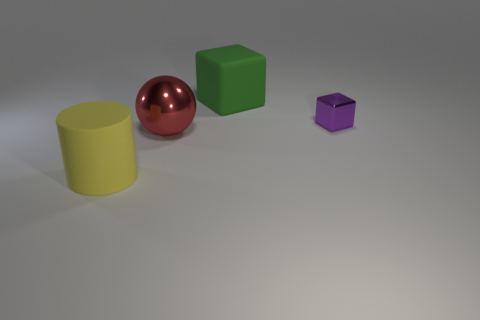How many small things are there?
Provide a short and direct response. 1. What color is the cylinder that is made of the same material as the large cube?
Provide a short and direct response. Yellow. What number of small objects are either brown rubber balls or yellow rubber cylinders?
Your response must be concise. 0. How many yellow things are behind the small block?
Make the answer very short. 0. There is a small metallic thing that is the same shape as the big green rubber thing; what is its color?
Make the answer very short. Purple. How many metal things are either small yellow things or big green objects?
Provide a short and direct response. 0. There is a large matte thing that is to the right of the large rubber object that is in front of the red ball; are there any small purple metal cubes left of it?
Give a very brief answer. No. The large metal thing has what color?
Your answer should be compact. Red. Does the rubber thing that is left of the large green matte block have the same shape as the green object?
Ensure brevity in your answer.  No. What number of things are yellow things or rubber objects that are right of the red shiny ball?
Give a very brief answer. 2. 